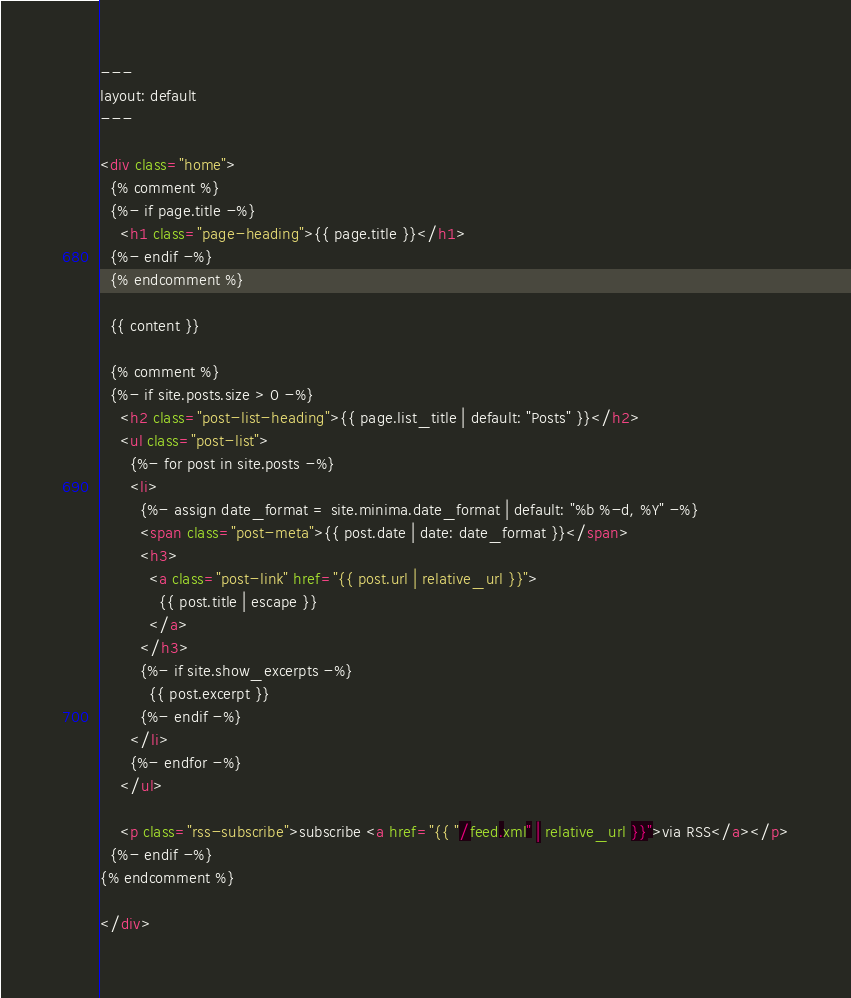Convert code to text. <code><loc_0><loc_0><loc_500><loc_500><_HTML_>---
layout: default
---

<div class="home">
  {% comment %}
  {%- if page.title -%}
    <h1 class="page-heading">{{ page.title }}</h1>
  {%- endif -%}
  {% endcomment %}

  {{ content }}

  {% comment %}
  {%- if site.posts.size > 0 -%}
    <h2 class="post-list-heading">{{ page.list_title | default: "Posts" }}</h2>
    <ul class="post-list">
      {%- for post in site.posts -%}
      <li>
        {%- assign date_format = site.minima.date_format | default: "%b %-d, %Y" -%}
        <span class="post-meta">{{ post.date | date: date_format }}</span>
        <h3>
          <a class="post-link" href="{{ post.url | relative_url }}">
            {{ post.title | escape }}
          </a>
        </h3>
        {%- if site.show_excerpts -%}
          {{ post.excerpt }}
        {%- endif -%}
      </li>
      {%- endfor -%}
    </ul>

    <p class="rss-subscribe">subscribe <a href="{{ "/feed.xml" | relative_url }}">via RSS</a></p>
  {%- endif -%}
{% endcomment %}

</div>
</code> 